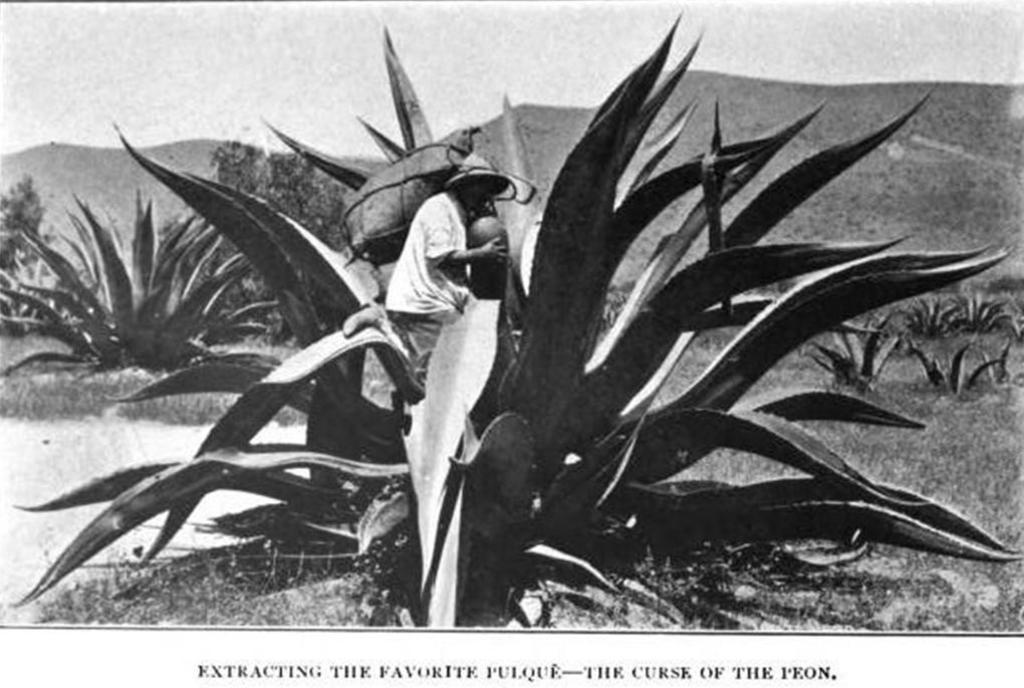What type of living organisms can be seen in the image? Plants are visible in the image. What is the person wearing a hat doing in the image? The person wearing a hat is standing on a plant. What can be seen in the distance in the image? Hills are visible in the background of the image. What is visible above the plants and hills in the image? The sky is visible in the background of the image. What is the color scheme of the image? The image is black and white. What type of glue is being used to control the plants in the image? There is no glue or control being used on the plants in the image; the person is simply standing on one. 